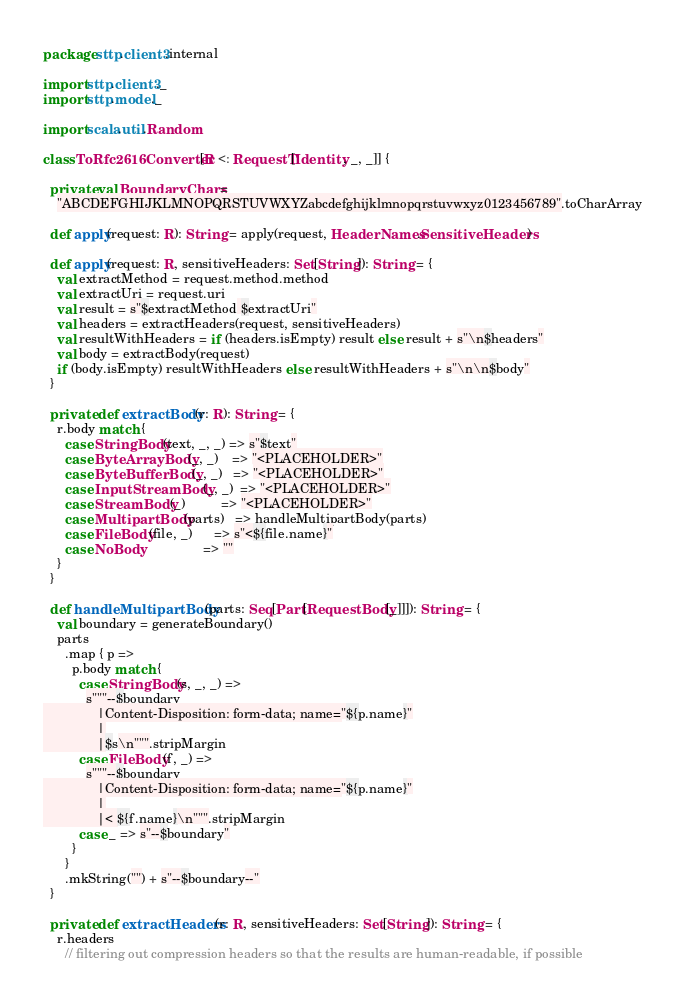Convert code to text. <code><loc_0><loc_0><loc_500><loc_500><_Scala_>package sttp.client3.internal

import sttp.client3._
import sttp.model._

import scala.util.Random

class ToRfc2616Converter[R <: RequestT[Identity, _, _]] {

  private val BoundaryChars =
    "ABCDEFGHIJKLMNOPQRSTUVWXYZabcdefghijklmnopqrstuvwxyz0123456789".toCharArray

  def apply(request: R): String = apply(request, HeaderNames.SensitiveHeaders)

  def apply(request: R, sensitiveHeaders: Set[String]): String = {
    val extractMethod = request.method.method
    val extractUri = request.uri
    val result = s"$extractMethod $extractUri"
    val headers = extractHeaders(request, sensitiveHeaders)
    val resultWithHeaders = if (headers.isEmpty) result else result + s"\n$headers"
    val body = extractBody(request)
    if (body.isEmpty) resultWithHeaders else resultWithHeaders + s"\n\n$body"
  }

  private def extractBody(r: R): String = {
    r.body match {
      case StringBody(text, _, _) => s"$text"
      case ByteArrayBody(_, _)    => "<PLACEHOLDER>"
      case ByteBufferBody(_, _)   => "<PLACEHOLDER>"
      case InputStreamBody(_, _)  => "<PLACEHOLDER>"
      case StreamBody(_)          => "<PLACEHOLDER>"
      case MultipartBody(parts)   => handleMultipartBody(parts)
      case FileBody(file, _)      => s"<${file.name}"
      case NoBody                 => ""
    }
  }

  def handleMultipartBody(parts: Seq[Part[RequestBody[_]]]): String = {
    val boundary = generateBoundary()
    parts
      .map { p =>
        p.body match {
          case StringBody(s, _, _) =>
            s"""--$boundary
               |Content-Disposition: form-data; name="${p.name}"
               |
               |$s\n""".stripMargin
          case FileBody(f, _) =>
            s"""--$boundary
               |Content-Disposition: form-data; name="${p.name}"
               |
               |< ${f.name}\n""".stripMargin
          case _ => s"--$boundary"
        }
      }
      .mkString("") + s"--$boundary--"
  }

  private def extractHeaders(r: R, sensitiveHeaders: Set[String]): String = {
    r.headers
      // filtering out compression headers so that the results are human-readable, if possible</code> 